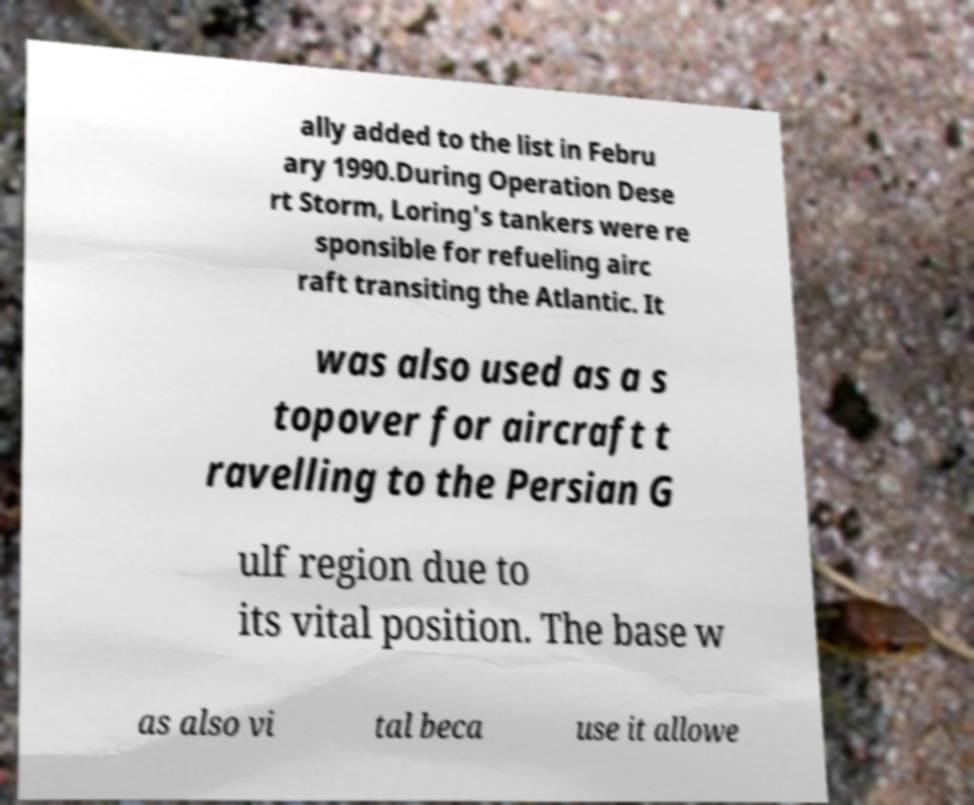What messages or text are displayed in this image? I need them in a readable, typed format. ally added to the list in Febru ary 1990.During Operation Dese rt Storm, Loring's tankers were re sponsible for refueling airc raft transiting the Atlantic. It was also used as a s topover for aircraft t ravelling to the Persian G ulf region due to its vital position. The base w as also vi tal beca use it allowe 